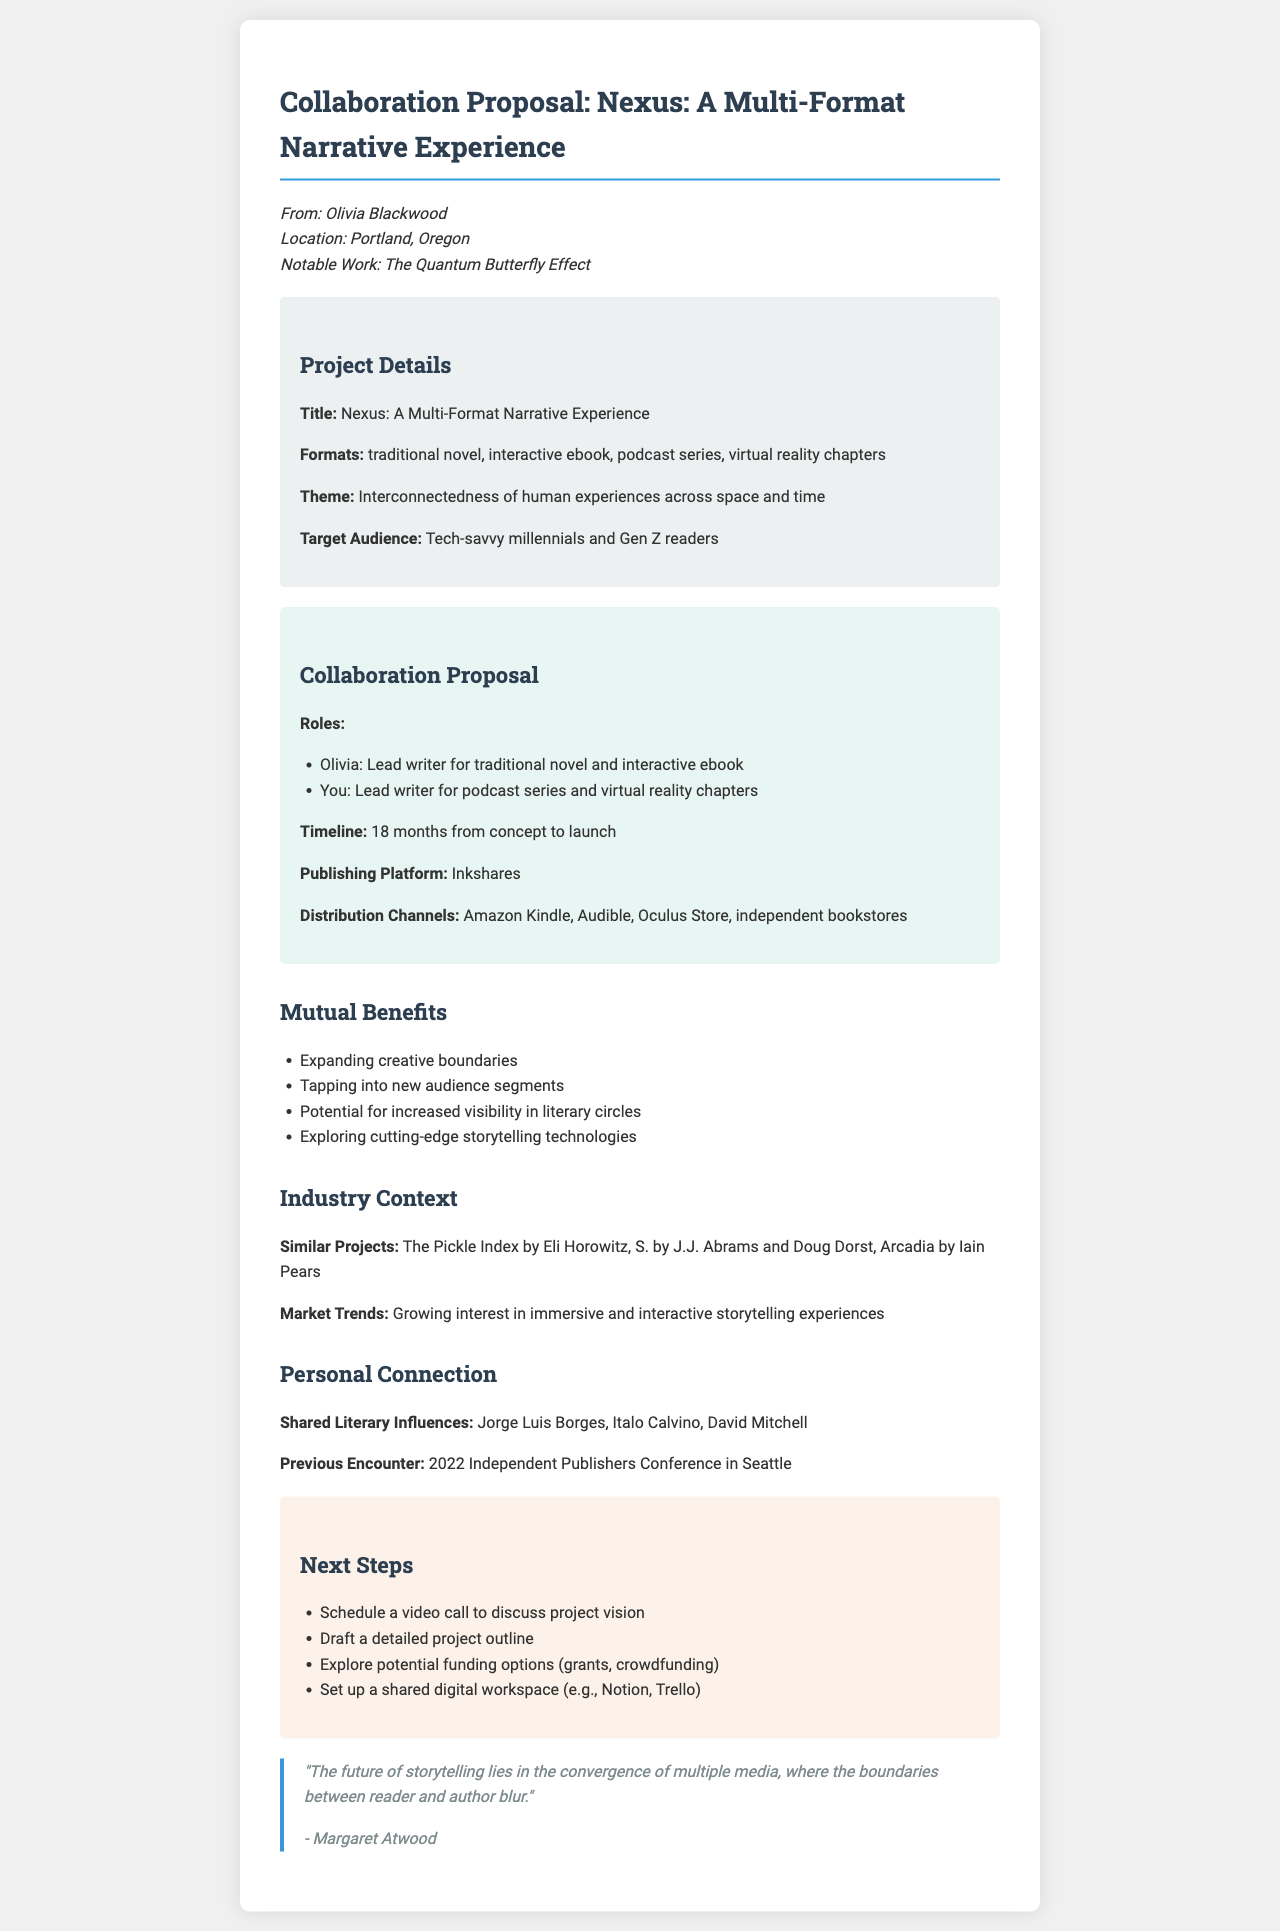What is the title of the project? The title of the project is listed in the document's project details section.
Answer: Nexus: A Multi-Format Narrative Experience Who is the sender of the letter? The sender's information is provided at the beginning of the document.
Answer: Olivia Blackwood What is the target audience for the project? The target audience is specified in the project details section of the document.
Answer: Tech-savvy millennials and Gen Z readers What will the recipient be responsible for in the collaboration? The roles assigned in the collaboration proposal section detail the recipient's responsibilities.
Answer: Lead writer for podcast series and virtual reality chapters How long is the proposed timeline for the project? The timeline for the project is mentioned in the collaboration proposal section.
Answer: 18 months What is one of the mutual benefits listed for collaboration? The document lists several mutual benefits, which can be found in the mutual benefits section.
Answer: Expanding creative boundaries What platform will the project be published on? The publishing platform is explicitly mentioned in the collaboration proposal section.
Answer: Inkshares Which literary influences do the authors share? The shared literary influences are specifically listed in the personal connection section of the document.
Answer: Jorge Luis Borges, Italo Calvino, David Mitchell What is a next step proposed in the document? The next steps are outlined at the end of the document.
Answer: Schedule a video call to discuss project vision 